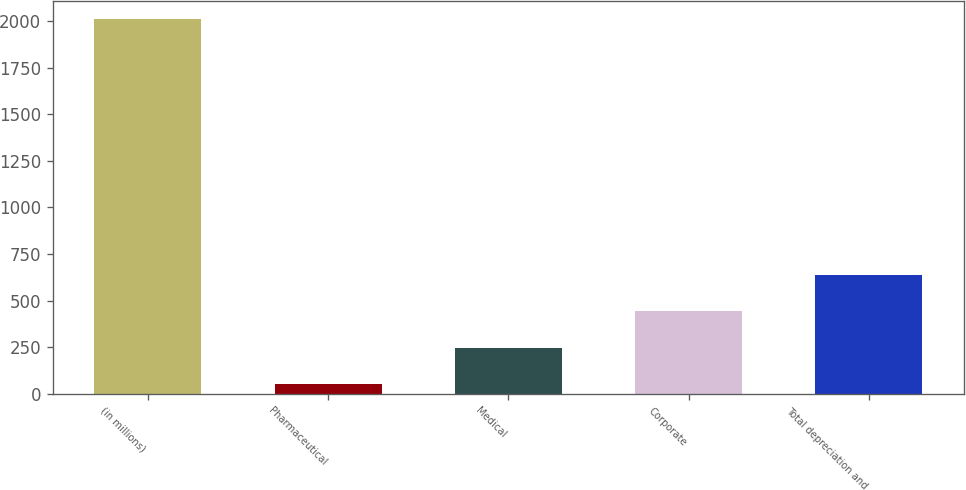Convert chart. <chart><loc_0><loc_0><loc_500><loc_500><bar_chart><fcel>(in millions)<fcel>Pharmaceutical<fcel>Medical<fcel>Corporate<fcel>Total depreciation and<nl><fcel>2010<fcel>50.9<fcel>246.81<fcel>442.72<fcel>638.63<nl></chart> 